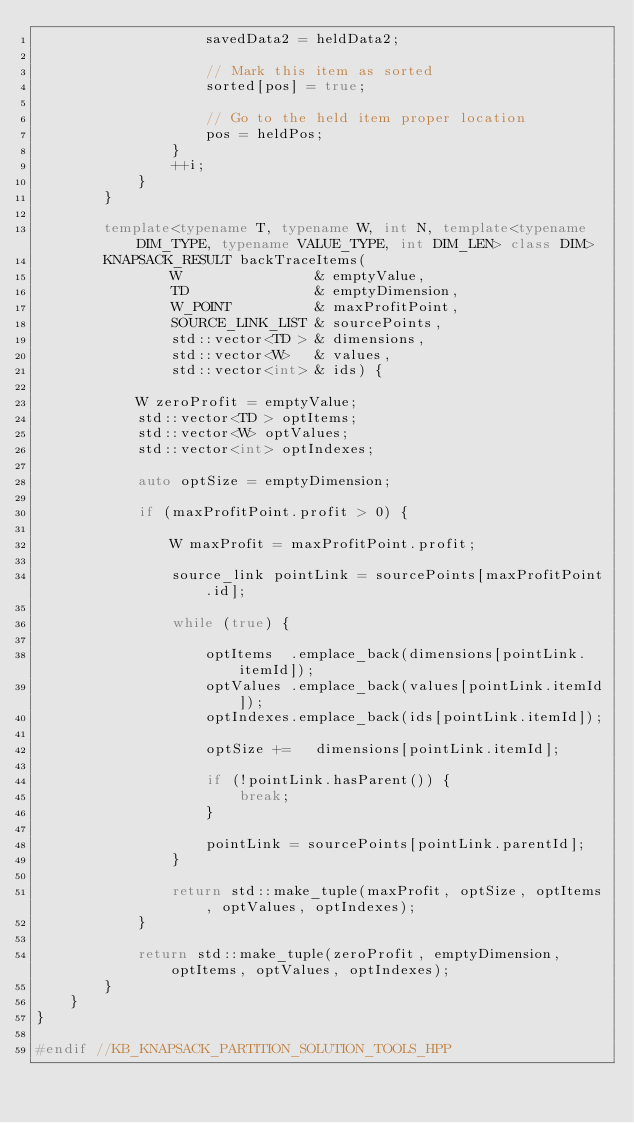<code> <loc_0><loc_0><loc_500><loc_500><_C++_>                    savedData2 = heldData2;

                    // Mark this item as sorted
                    sorted[pos] = true;

                    // Go to the held item proper location
                    pos = heldPos;
                }
                ++i;
            }
        }

        template<typename T, typename W, int N, template<typename DIM_TYPE, typename VALUE_TYPE, int DIM_LEN> class DIM>
        KNAPSACK_RESULT backTraceItems(
                W                & emptyValue,
                TD               & emptyDimension,
                W_POINT          & maxProfitPoint,
                SOURCE_LINK_LIST & sourcePoints,
                std::vector<TD > & dimensions,
                std::vector<W>   & values,
                std::vector<int> & ids) {

            W zeroProfit = emptyValue;
            std::vector<TD > optItems;
            std::vector<W> optValues;
            std::vector<int> optIndexes;

            auto optSize = emptyDimension;

            if (maxProfitPoint.profit > 0) {

                W maxProfit = maxProfitPoint.profit;

                source_link pointLink = sourcePoints[maxProfitPoint.id];

                while (true) {

                    optItems  .emplace_back(dimensions[pointLink.itemId]);
                    optValues .emplace_back(values[pointLink.itemId]);
                    optIndexes.emplace_back(ids[pointLink.itemId]);

                    optSize +=   dimensions[pointLink.itemId];

                    if (!pointLink.hasParent()) {
                        break;
                    }

                    pointLink = sourcePoints[pointLink.parentId];
                }

                return std::make_tuple(maxProfit, optSize, optItems, optValues, optIndexes);
            }

            return std::make_tuple(zeroProfit, emptyDimension, optItems, optValues, optIndexes);
        }
    }
}

#endif //KB_KNAPSACK_PARTITION_SOLUTION_TOOLS_HPP
</code> 